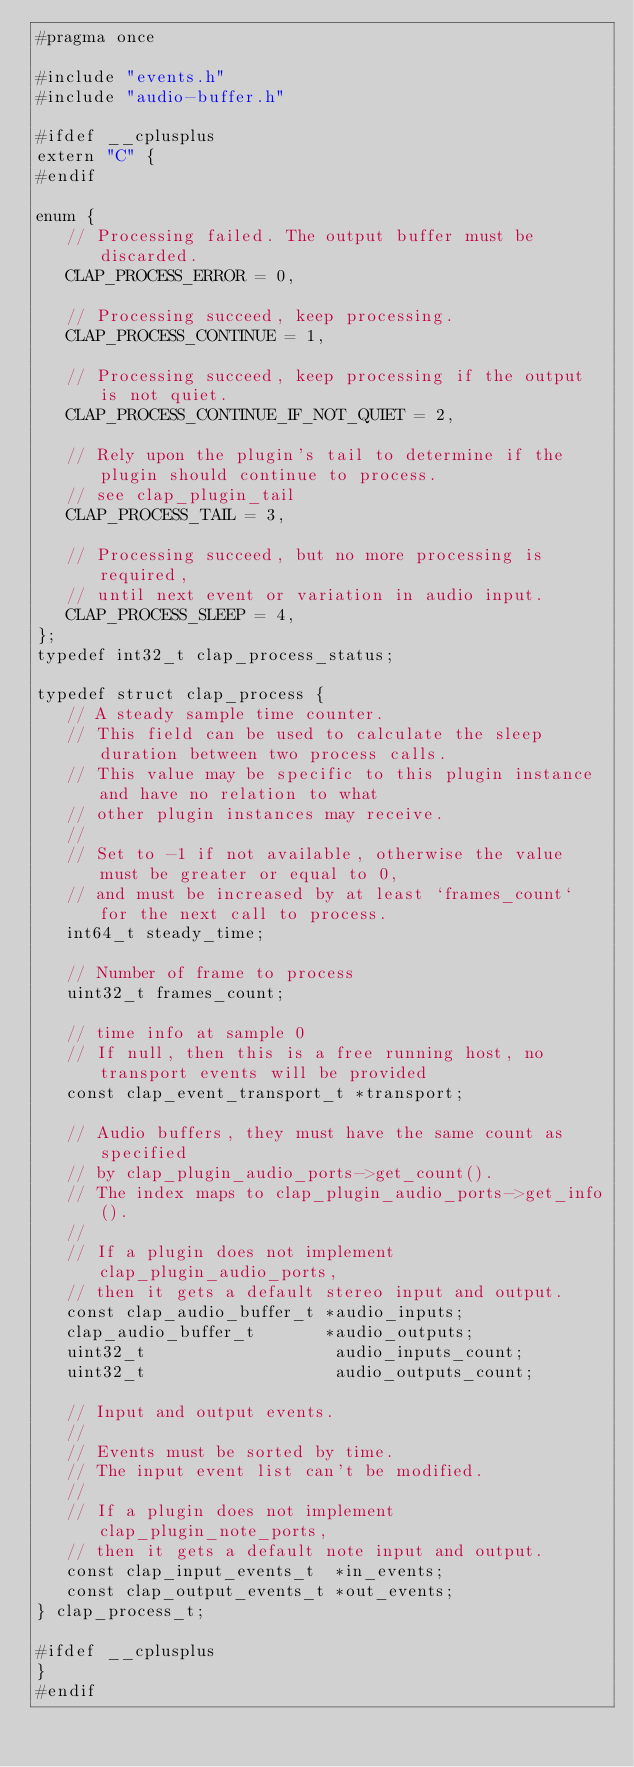Convert code to text. <code><loc_0><loc_0><loc_500><loc_500><_C_>#pragma once

#include "events.h"
#include "audio-buffer.h"

#ifdef __cplusplus
extern "C" {
#endif

enum {
   // Processing failed. The output buffer must be discarded.
   CLAP_PROCESS_ERROR = 0,

   // Processing succeed, keep processing.
   CLAP_PROCESS_CONTINUE = 1,

   // Processing succeed, keep processing if the output is not quiet.
   CLAP_PROCESS_CONTINUE_IF_NOT_QUIET = 2,

   // Rely upon the plugin's tail to determine if the plugin should continue to process.
   // see clap_plugin_tail
   CLAP_PROCESS_TAIL = 3,

   // Processing succeed, but no more processing is required,
   // until next event or variation in audio input.
   CLAP_PROCESS_SLEEP = 4,
};
typedef int32_t clap_process_status;

typedef struct clap_process {
   // A steady sample time counter.
   // This field can be used to calculate the sleep duration between two process calls.
   // This value may be specific to this plugin instance and have no relation to what
   // other plugin instances may receive.
   //
   // Set to -1 if not available, otherwise the value must be greater or equal to 0,
   // and must be increased by at least `frames_count` for the next call to process.
   int64_t steady_time;

   // Number of frame to process
   uint32_t frames_count;

   // time info at sample 0
   // If null, then this is a free running host, no transport events will be provided
   const clap_event_transport_t *transport;

   // Audio buffers, they must have the same count as specified
   // by clap_plugin_audio_ports->get_count().
   // The index maps to clap_plugin_audio_ports->get_info().
   //
   // If a plugin does not implement clap_plugin_audio_ports,
   // then it gets a default stereo input and output.
   const clap_audio_buffer_t *audio_inputs;
   clap_audio_buffer_t       *audio_outputs;
   uint32_t                   audio_inputs_count;
   uint32_t                   audio_outputs_count;

   // Input and output events.
   //
   // Events must be sorted by time.
   // The input event list can't be modified.
   //
   // If a plugin does not implement clap_plugin_note_ports,
   // then it gets a default note input and output.
   const clap_input_events_t  *in_events;
   const clap_output_events_t *out_events;
} clap_process_t;

#ifdef __cplusplus
}
#endif
</code> 